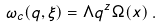<formula> <loc_0><loc_0><loc_500><loc_500>\omega _ { c } ( q , \xi ) = \Lambda q ^ { z } \Omega ( x ) \, .</formula> 